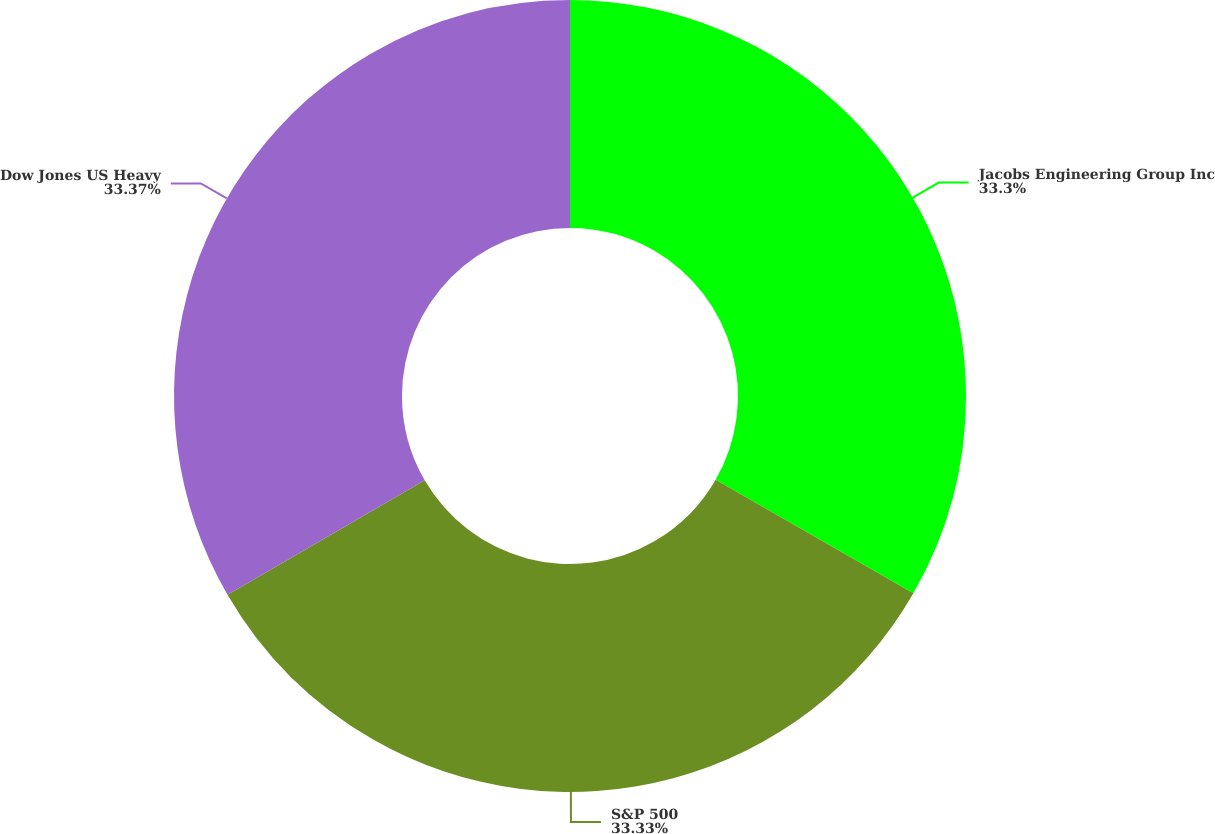Convert chart to OTSL. <chart><loc_0><loc_0><loc_500><loc_500><pie_chart><fcel>Jacobs Engineering Group Inc<fcel>S&P 500<fcel>Dow Jones US Heavy<nl><fcel>33.3%<fcel>33.33%<fcel>33.37%<nl></chart> 